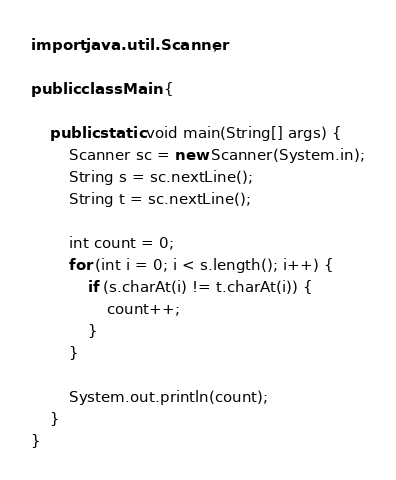Convert code to text. <code><loc_0><loc_0><loc_500><loc_500><_Java_>import java.util.Scanner;

public class Main {

    public static void main(String[] args) {
        Scanner sc = new Scanner(System.in);
        String s = sc.nextLine();
        String t = sc.nextLine();

        int count = 0;
        for (int i = 0; i < s.length(); i++) {
            if (s.charAt(i) != t.charAt(i)) {
                count++;
            }
        }

        System.out.println(count);
    }
}</code> 